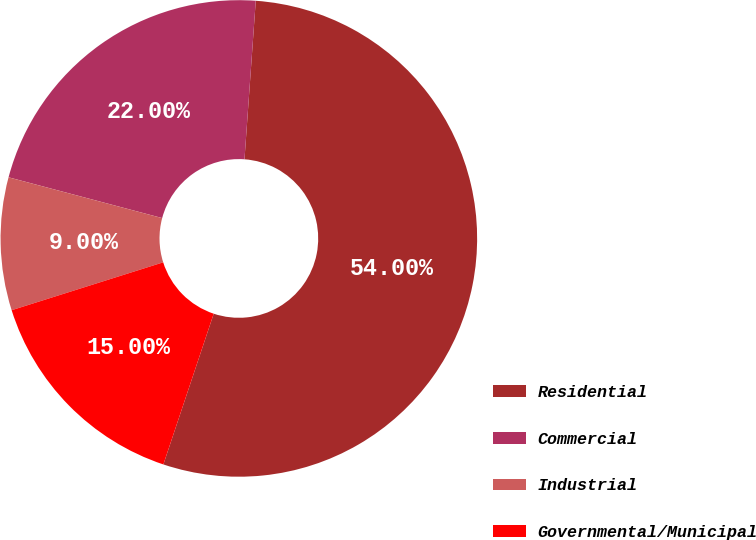Convert chart. <chart><loc_0><loc_0><loc_500><loc_500><pie_chart><fcel>Residential<fcel>Commercial<fcel>Industrial<fcel>Governmental/Municipal<nl><fcel>54.0%<fcel>22.0%<fcel>9.0%<fcel>15.0%<nl></chart> 